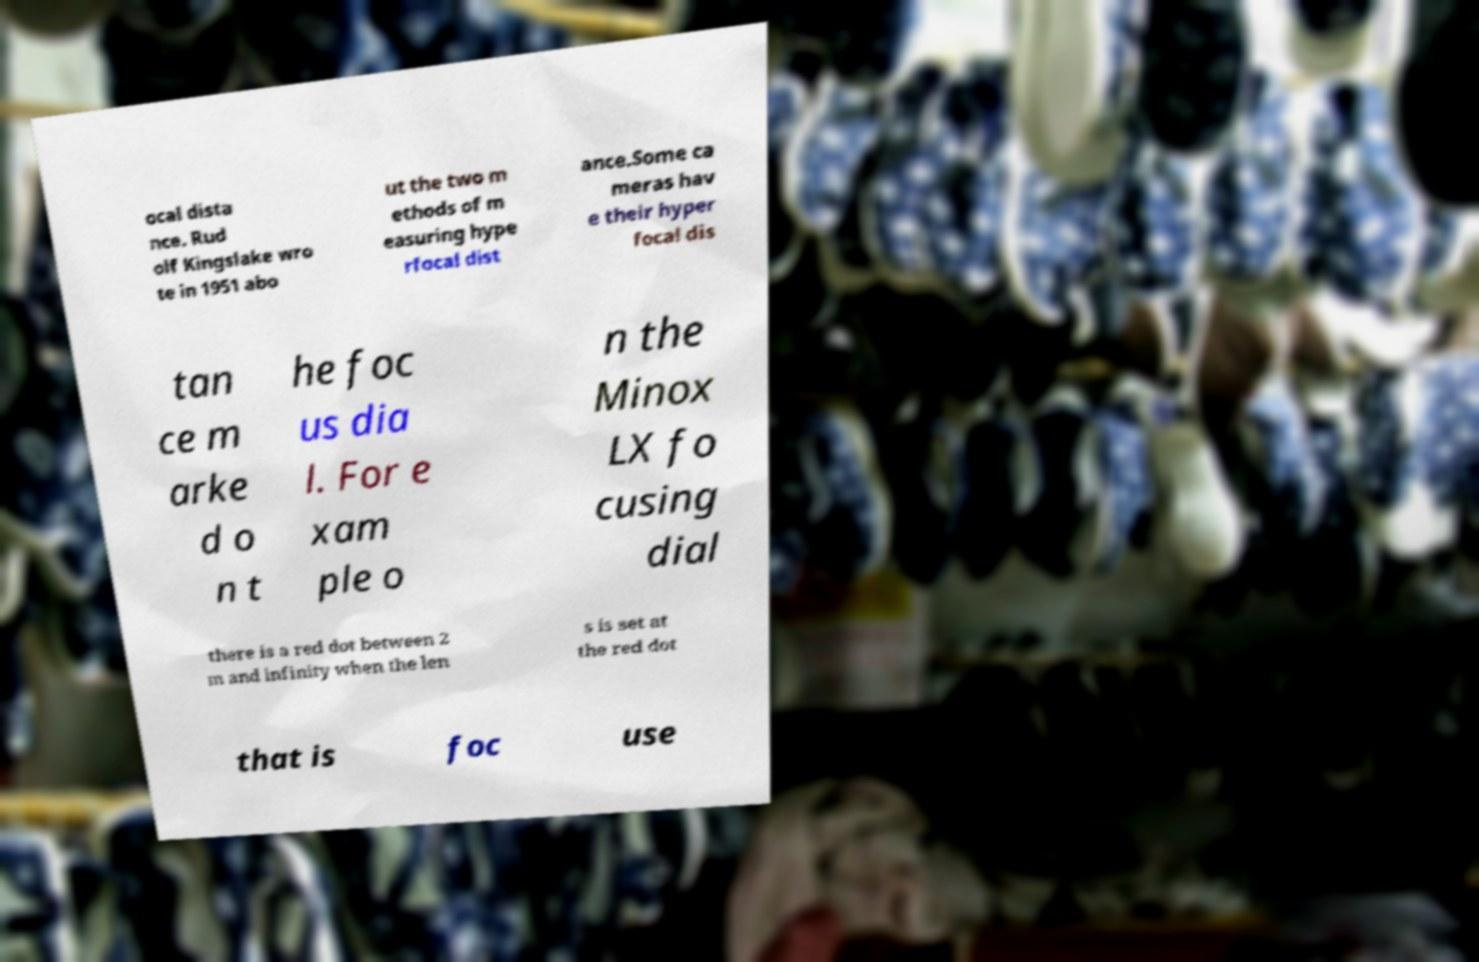Could you extract and type out the text from this image? ocal dista nce. Rud olf Kingslake wro te in 1951 abo ut the two m ethods of m easuring hype rfocal dist ance.Some ca meras hav e their hyper focal dis tan ce m arke d o n t he foc us dia l. For e xam ple o n the Minox LX fo cusing dial there is a red dot between 2 m and infinity when the len s is set at the red dot that is foc use 